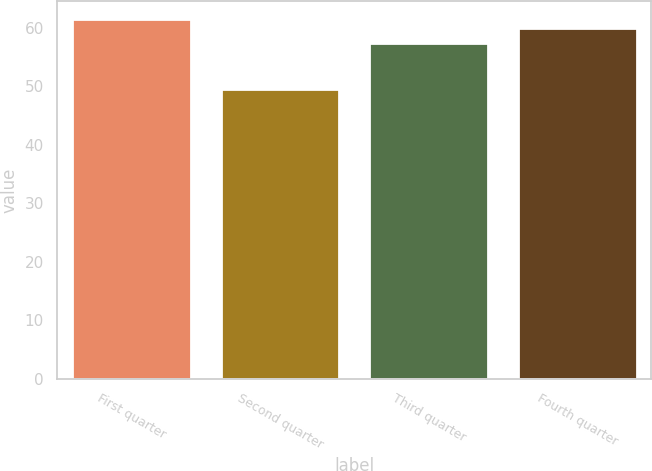<chart> <loc_0><loc_0><loc_500><loc_500><bar_chart><fcel>First quarter<fcel>Second quarter<fcel>Third quarter<fcel>Fourth quarter<nl><fcel>61.5<fcel>49.5<fcel>57.35<fcel>60<nl></chart> 